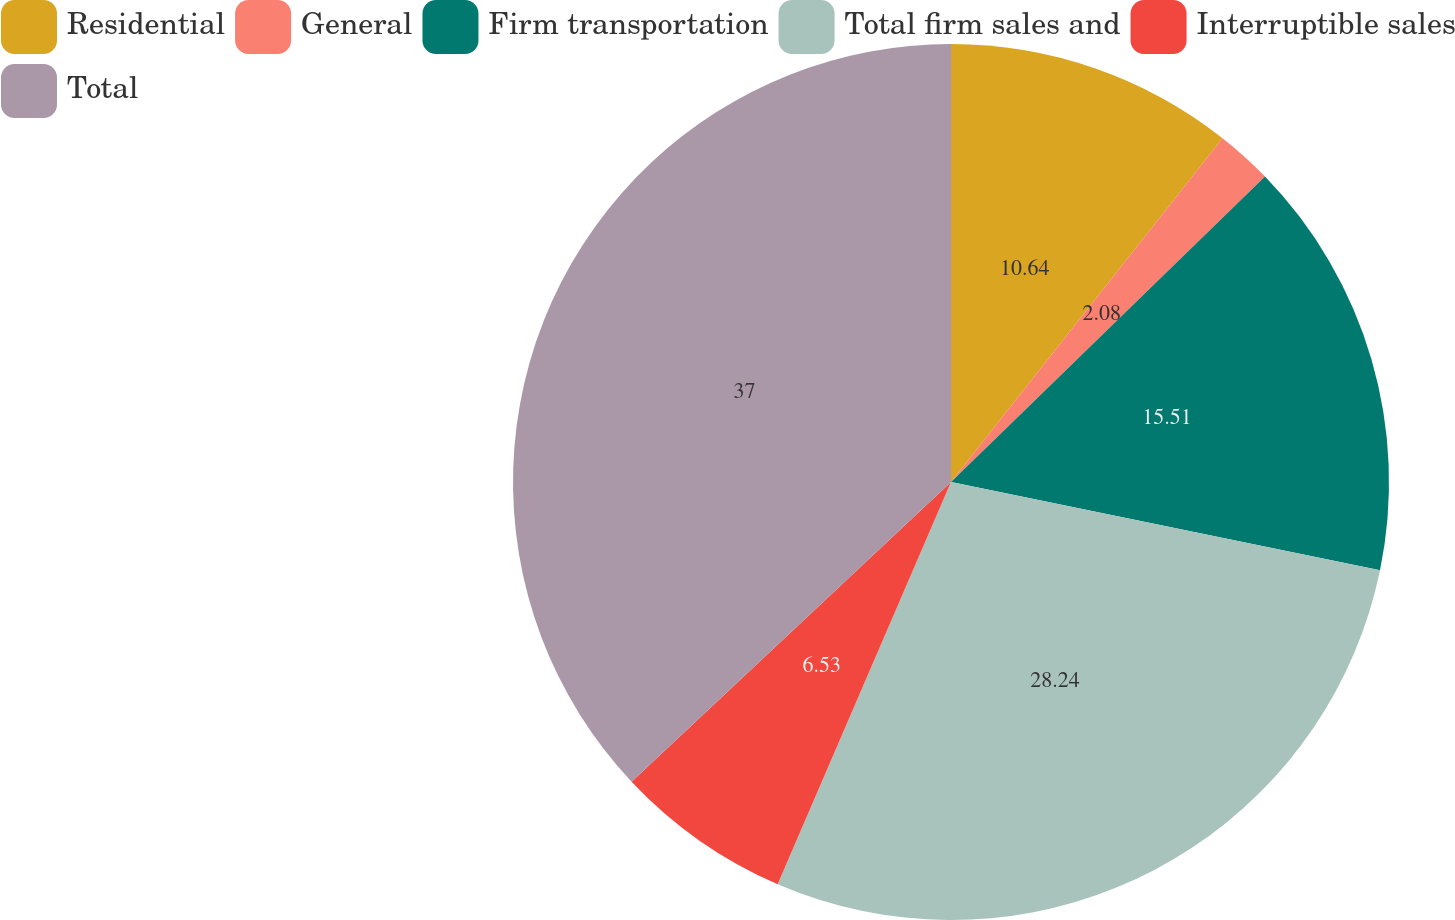Convert chart. <chart><loc_0><loc_0><loc_500><loc_500><pie_chart><fcel>Residential<fcel>General<fcel>Firm transportation<fcel>Total firm sales and<fcel>Interruptible sales<fcel>Total<nl><fcel>10.64%<fcel>2.08%<fcel>15.51%<fcel>28.24%<fcel>6.53%<fcel>36.99%<nl></chart> 